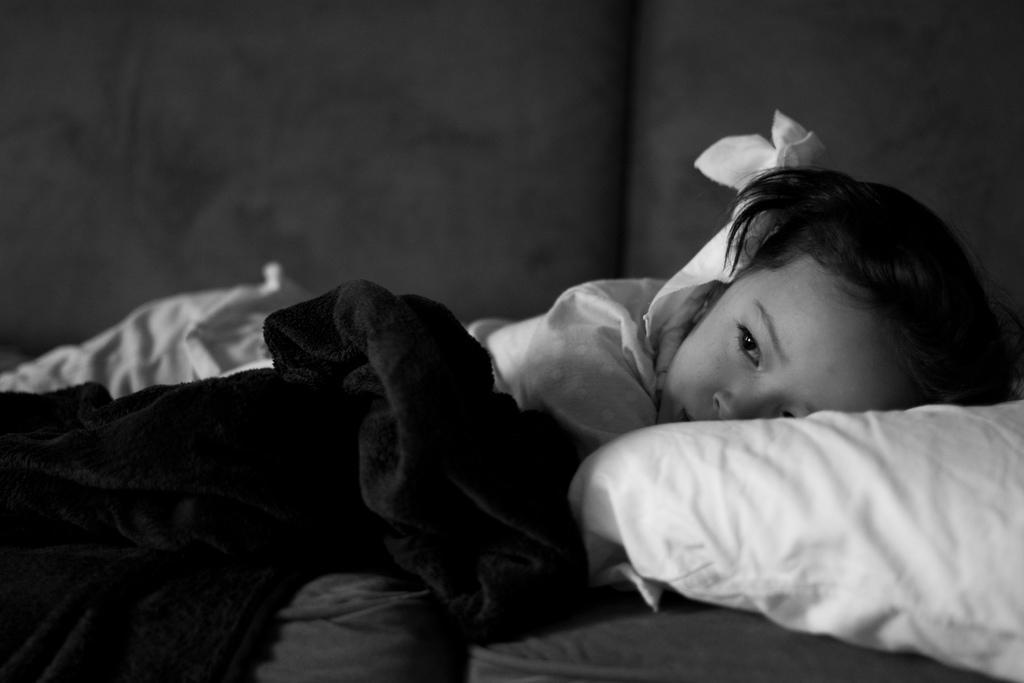What is the color scheme of the image? The image is black and white. What is the girl doing in the image? The girl is laying on the bed. What is on the bed with the girl? There is a pillow on the bed. What type of cow can be seen grazing on the dirt in the image? There is no cow or dirt present in the image; it is a black and white image of a girl laying on a bed with a pillow. 